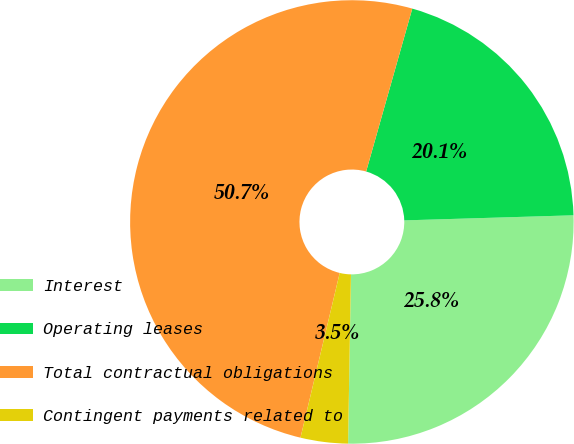Convert chart to OTSL. <chart><loc_0><loc_0><loc_500><loc_500><pie_chart><fcel>Interest<fcel>Operating leases<fcel>Total contractual obligations<fcel>Contingent payments related to<nl><fcel>25.75%<fcel>20.13%<fcel>50.67%<fcel>3.45%<nl></chart> 